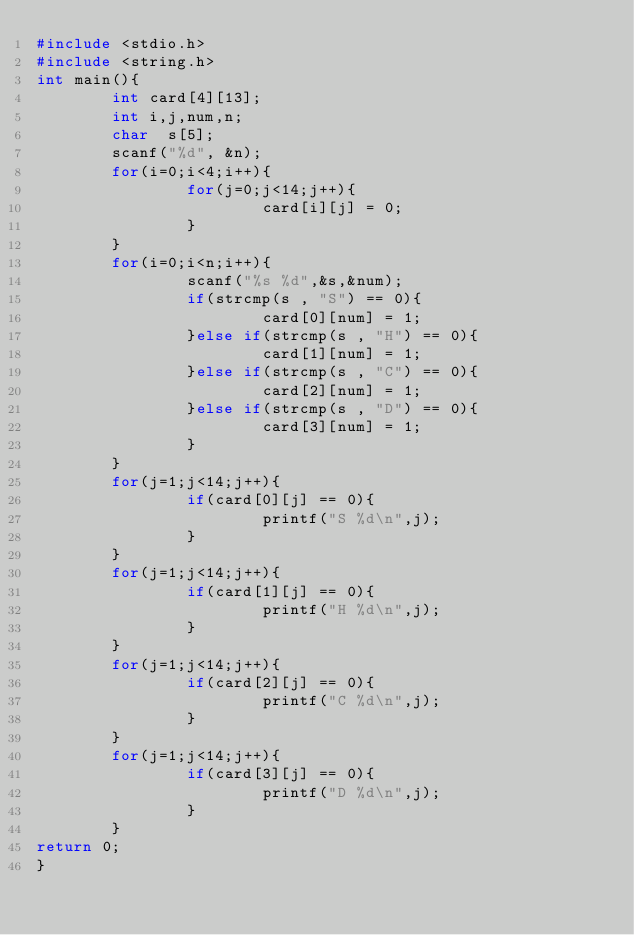Convert code to text. <code><loc_0><loc_0><loc_500><loc_500><_C_>#include <stdio.h>
#include <string.h>
int main(){
        int card[4][13];
        int i,j,num,n;
        char  s[5];
        scanf("%d", &n);
        for(i=0;i<4;i++){
                for(j=0;j<14;j++){
                        card[i][j] = 0;
                }
        }
        for(i=0;i<n;i++){
                scanf("%s %d",&s,&num);
                if(strcmp(s , "S") == 0){
                        card[0][num] = 1;
                }else if(strcmp(s , "H") == 0){
                        card[1][num] = 1;
                }else if(strcmp(s , "C") == 0){
                        card[2][num] = 1;
                }else if(strcmp(s , "D") == 0){
                        card[3][num] = 1;
                }
        }
        for(j=1;j<14;j++){
                if(card[0][j] == 0){
                        printf("S %d\n",j);
                }
        }
        for(j=1;j<14;j++){
                if(card[1][j] == 0){
                        printf("H %d\n",j);
                }
        }
        for(j=1;j<14;j++){
                if(card[2][j] == 0){
                        printf("C %d\n",j);
                }
        }
        for(j=1;j<14;j++){
                if(card[3][j] == 0){
                        printf("D %d\n",j);
                }
        }
return 0;
}</code> 